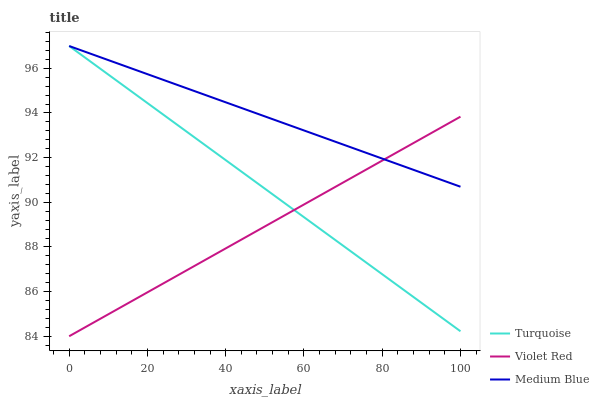Does Medium Blue have the minimum area under the curve?
Answer yes or no. No. Does Violet Red have the maximum area under the curve?
Answer yes or no. No. Is Violet Red the smoothest?
Answer yes or no. No. Is Violet Red the roughest?
Answer yes or no. No. Does Medium Blue have the lowest value?
Answer yes or no. No. Does Violet Red have the highest value?
Answer yes or no. No. 